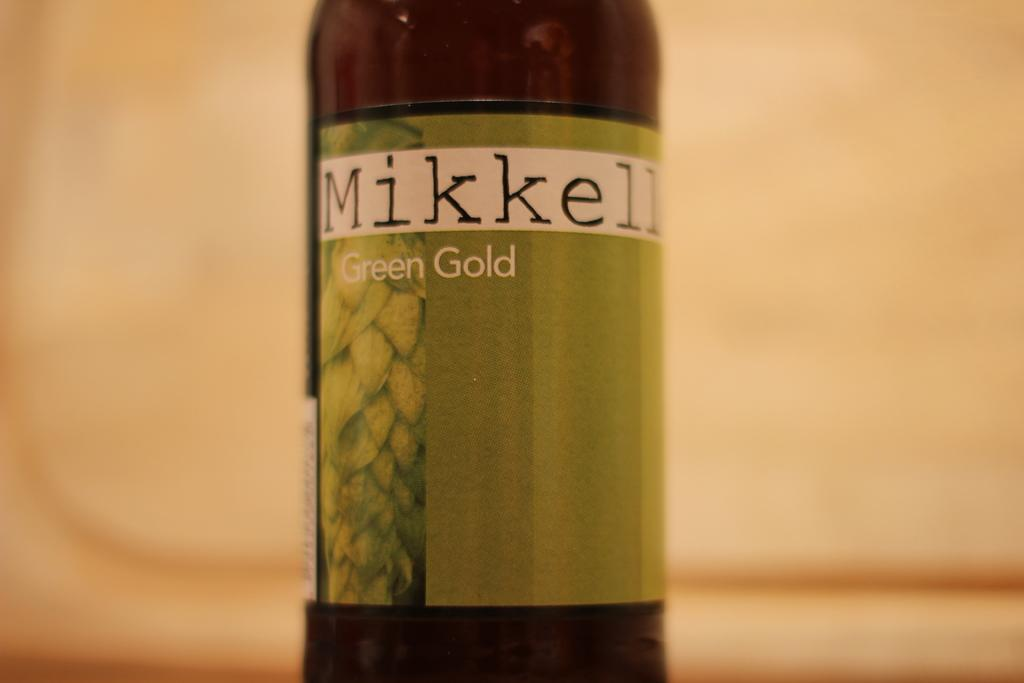<image>
Share a concise interpretation of the image provided. A bottle has the brand name Mikkell on it. 